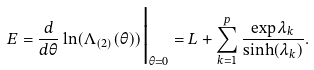<formula> <loc_0><loc_0><loc_500><loc_500>E = \frac { d } { d \theta } \ln ( \Lambda _ { ( 2 ) } ( \theta ) ) \Big | _ { \theta = 0 } = L + \sum _ { k = 1 } ^ { p } \frac { \exp { \lambda _ { k } } } { \sinh ( \lambda _ { k } ) } .</formula> 